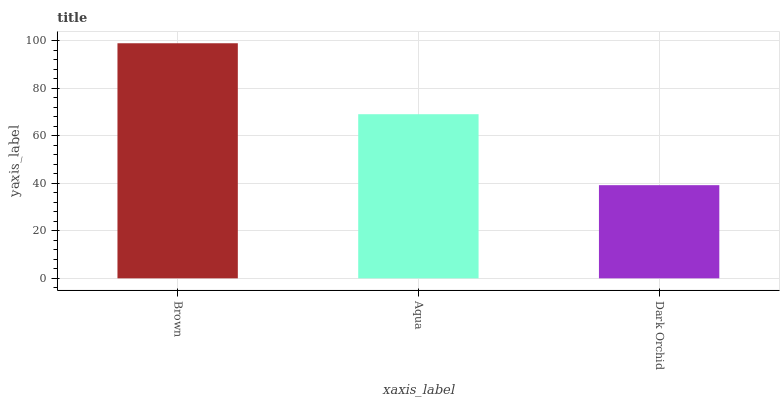Is Dark Orchid the minimum?
Answer yes or no. Yes. Is Brown the maximum?
Answer yes or no. Yes. Is Aqua the minimum?
Answer yes or no. No. Is Aqua the maximum?
Answer yes or no. No. Is Brown greater than Aqua?
Answer yes or no. Yes. Is Aqua less than Brown?
Answer yes or no. Yes. Is Aqua greater than Brown?
Answer yes or no. No. Is Brown less than Aqua?
Answer yes or no. No. Is Aqua the high median?
Answer yes or no. Yes. Is Aqua the low median?
Answer yes or no. Yes. Is Brown the high median?
Answer yes or no. No. Is Brown the low median?
Answer yes or no. No. 